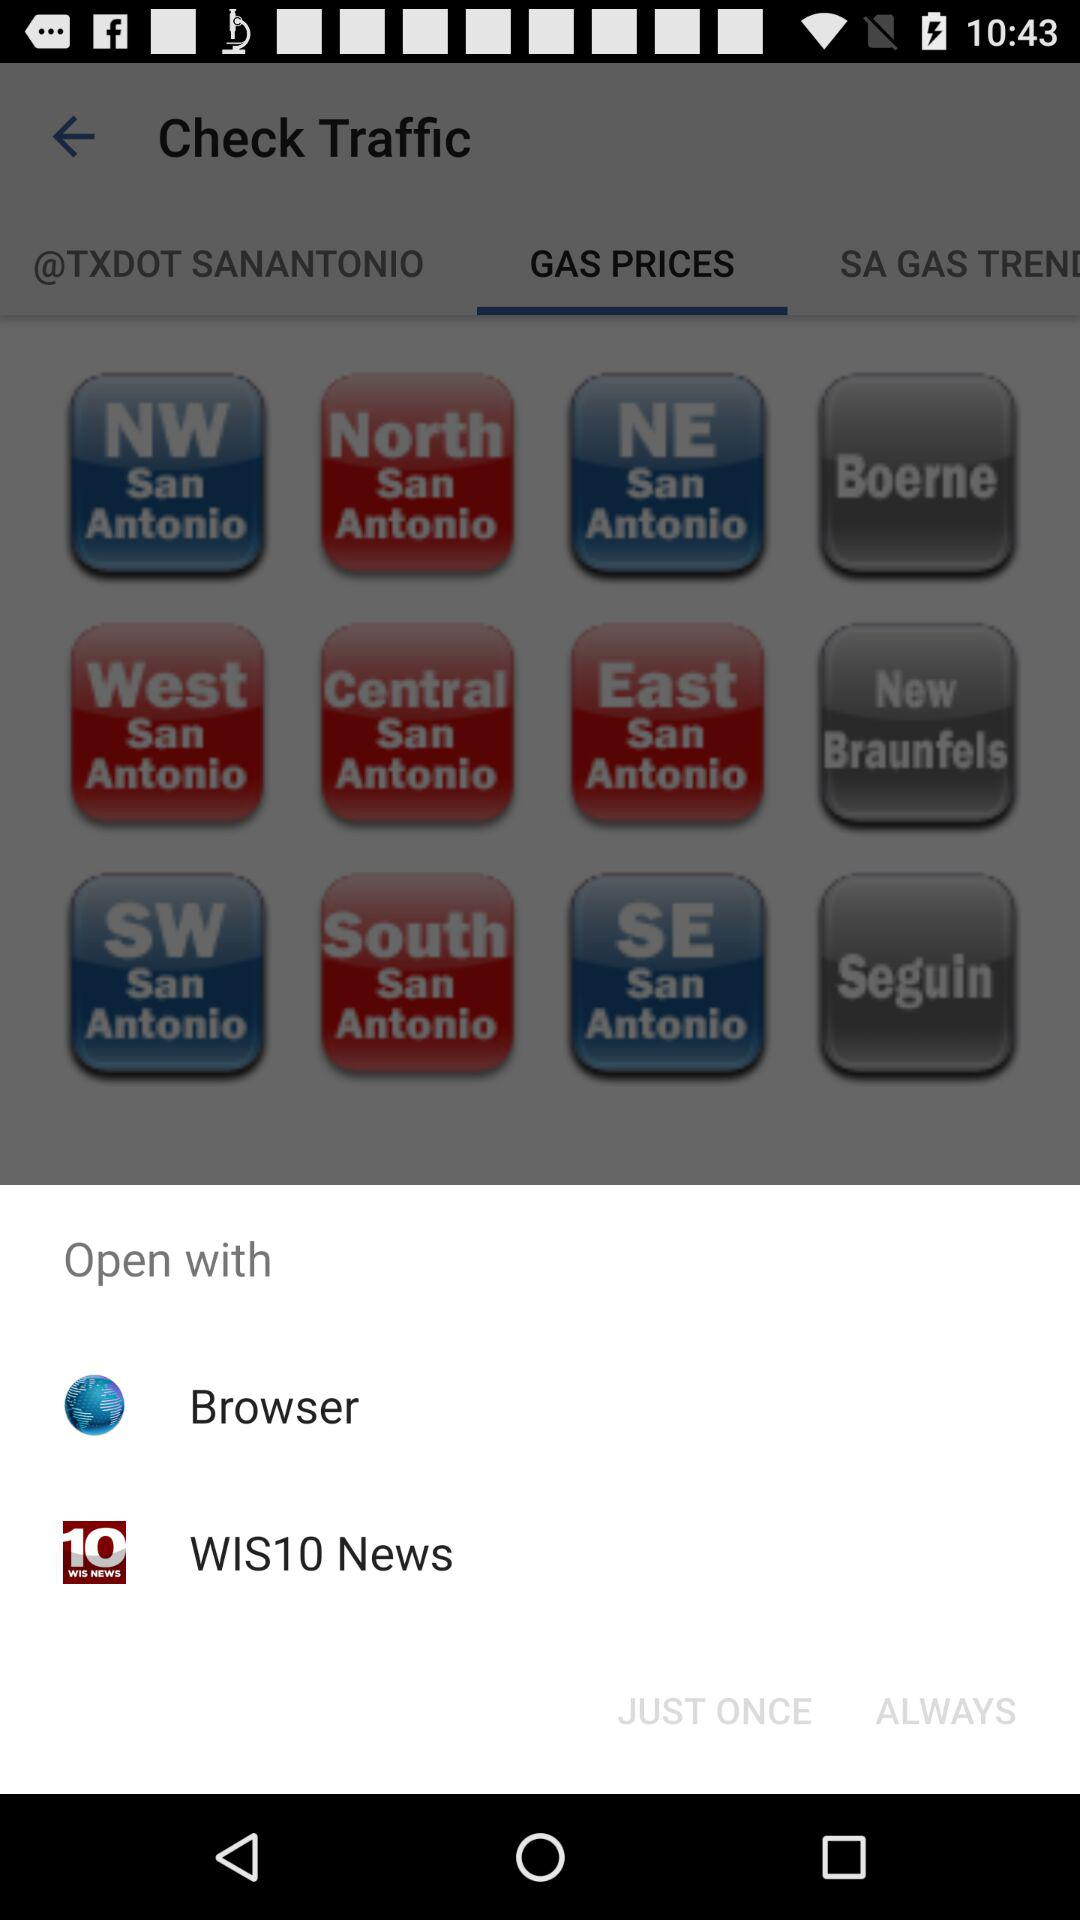With what applications can we open? You can open with "WIS10 News". 